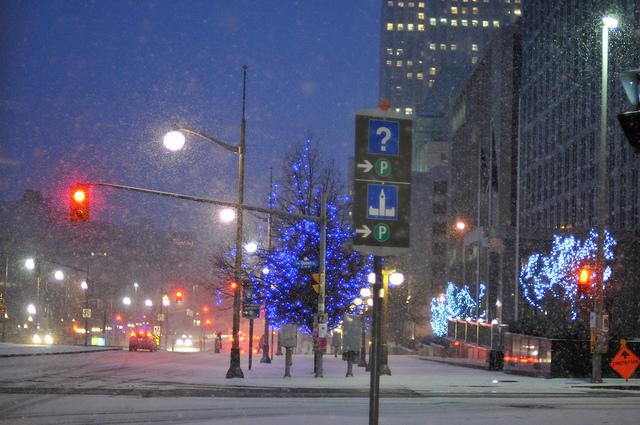Why have they made the trees blue?

Choices:
A) visibility
B) attract pollinators
C) protect leaves
D) holidays holidays 